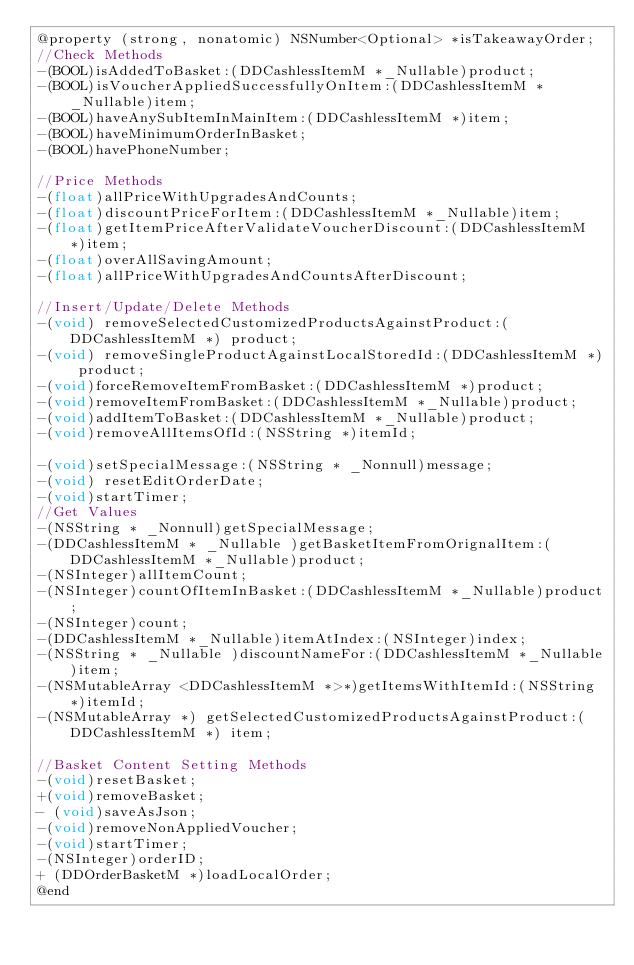<code> <loc_0><loc_0><loc_500><loc_500><_C_>@property (strong, nonatomic) NSNumber<Optional> *isTakeawayOrder;
//Check Methods
-(BOOL)isAddedToBasket:(DDCashlessItemM *_Nullable)product;
-(BOOL)isVoucherAppliedSuccessfullyOnItem:(DDCashlessItemM *_Nullable)item;
-(BOOL)haveAnySubItemInMainItem:(DDCashlessItemM *)item;
-(BOOL)haveMinimumOrderInBasket;
-(BOOL)havePhoneNumber;

//Price Methods
-(float)allPriceWithUpgradesAndCounts;
-(float)discountPriceForItem:(DDCashlessItemM *_Nullable)item;
-(float)getItemPriceAfterValidateVoucherDiscount:(DDCashlessItemM *)item;
-(float)overAllSavingAmount;
-(float)allPriceWithUpgradesAndCountsAfterDiscount;

//Insert/Update/Delete Methods
-(void) removeSelectedCustomizedProductsAgainstProduct:(DDCashlessItemM *) product;
-(void) removeSingleProductAgainstLocalStoredId:(DDCashlessItemM *) product;
-(void)forceRemoveItemFromBasket:(DDCashlessItemM *)product;
-(void)removeItemFromBasket:(DDCashlessItemM *_Nullable)product;
-(void)addItemToBasket:(DDCashlessItemM *_Nullable)product;
-(void)removeAllItemsOfId:(NSString *)itemId;

-(void)setSpecialMessage:(NSString * _Nonnull)message;
-(void) resetEditOrderDate;
-(void)startTimer;
//Get Values
-(NSString * _Nonnull)getSpecialMessage;
-(DDCashlessItemM * _Nullable )getBasketItemFromOrignalItem:(DDCashlessItemM *_Nullable)product;
-(NSInteger)allItemCount;
-(NSInteger)countOfItemInBasket:(DDCashlessItemM *_Nullable)product;
-(NSInteger)count;
-(DDCashlessItemM *_Nullable)itemAtIndex:(NSInteger)index;
-(NSString * _Nullable )discountNameFor:(DDCashlessItemM *_Nullable)item;
-(NSMutableArray <DDCashlessItemM *>*)getItemsWithItemId:(NSString *)itemId;
-(NSMutableArray *) getSelectedCustomizedProductsAgainstProduct:(DDCashlessItemM *) item;

//Basket Content Setting Methods
-(void)resetBasket;
+(void)removeBasket;
- (void)saveAsJson;
-(void)removeNonAppliedVoucher;
-(void)startTimer;
-(NSInteger)orderID;
+ (DDOrderBasketM *)loadLocalOrder;
@end
</code> 